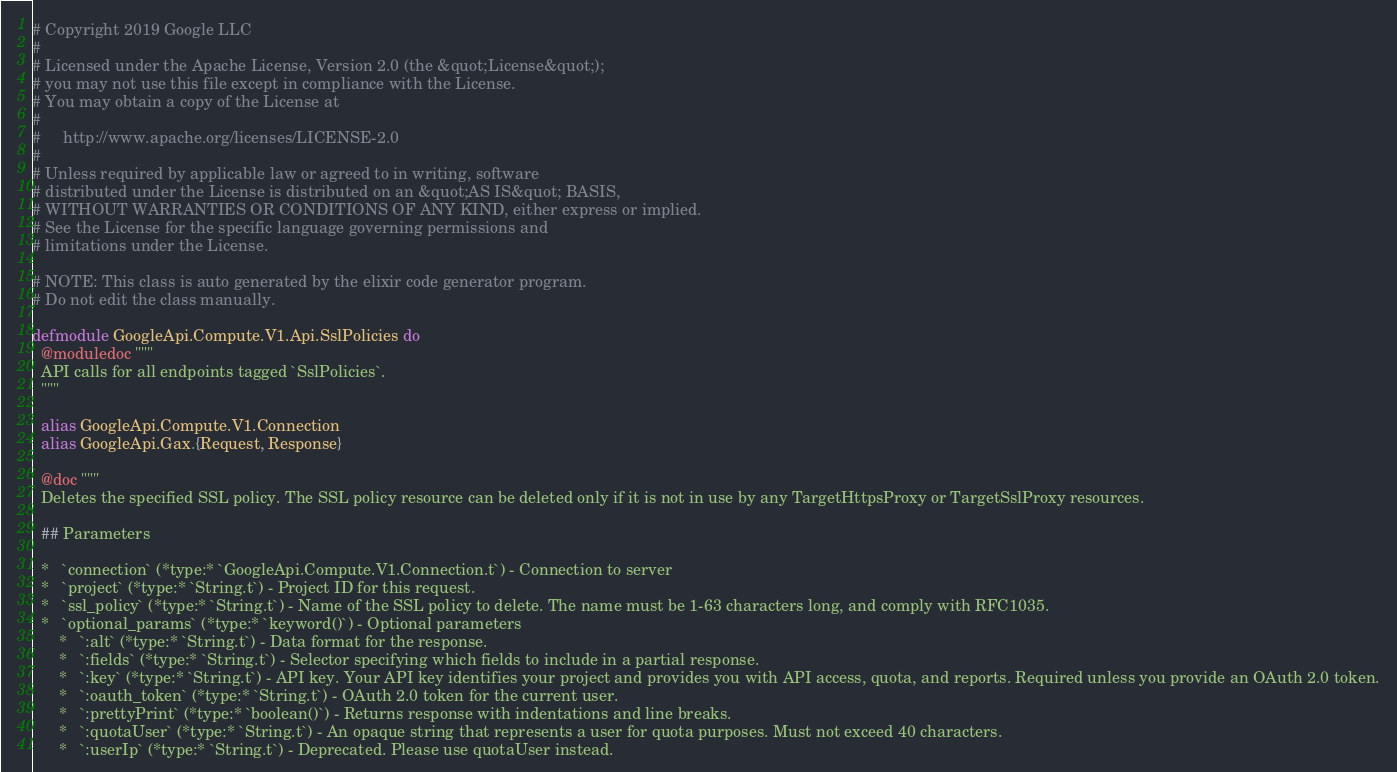Convert code to text. <code><loc_0><loc_0><loc_500><loc_500><_Elixir_># Copyright 2019 Google LLC
#
# Licensed under the Apache License, Version 2.0 (the &quot;License&quot;);
# you may not use this file except in compliance with the License.
# You may obtain a copy of the License at
#
#     http://www.apache.org/licenses/LICENSE-2.0
#
# Unless required by applicable law or agreed to in writing, software
# distributed under the License is distributed on an &quot;AS IS&quot; BASIS,
# WITHOUT WARRANTIES OR CONDITIONS OF ANY KIND, either express or implied.
# See the License for the specific language governing permissions and
# limitations under the License.

# NOTE: This class is auto generated by the elixir code generator program.
# Do not edit the class manually.

defmodule GoogleApi.Compute.V1.Api.SslPolicies do
  @moduledoc """
  API calls for all endpoints tagged `SslPolicies`.
  """

  alias GoogleApi.Compute.V1.Connection
  alias GoogleApi.Gax.{Request, Response}

  @doc """
  Deletes the specified SSL policy. The SSL policy resource can be deleted only if it is not in use by any TargetHttpsProxy or TargetSslProxy resources.

  ## Parameters

  *   `connection` (*type:* `GoogleApi.Compute.V1.Connection.t`) - Connection to server
  *   `project` (*type:* `String.t`) - Project ID for this request.
  *   `ssl_policy` (*type:* `String.t`) - Name of the SSL policy to delete. The name must be 1-63 characters long, and comply with RFC1035.
  *   `optional_params` (*type:* `keyword()`) - Optional parameters
      *   `:alt` (*type:* `String.t`) - Data format for the response.
      *   `:fields` (*type:* `String.t`) - Selector specifying which fields to include in a partial response.
      *   `:key` (*type:* `String.t`) - API key. Your API key identifies your project and provides you with API access, quota, and reports. Required unless you provide an OAuth 2.0 token.
      *   `:oauth_token` (*type:* `String.t`) - OAuth 2.0 token for the current user.
      *   `:prettyPrint` (*type:* `boolean()`) - Returns response with indentations and line breaks.
      *   `:quotaUser` (*type:* `String.t`) - An opaque string that represents a user for quota purposes. Must not exceed 40 characters.
      *   `:userIp` (*type:* `String.t`) - Deprecated. Please use quotaUser instead.</code> 